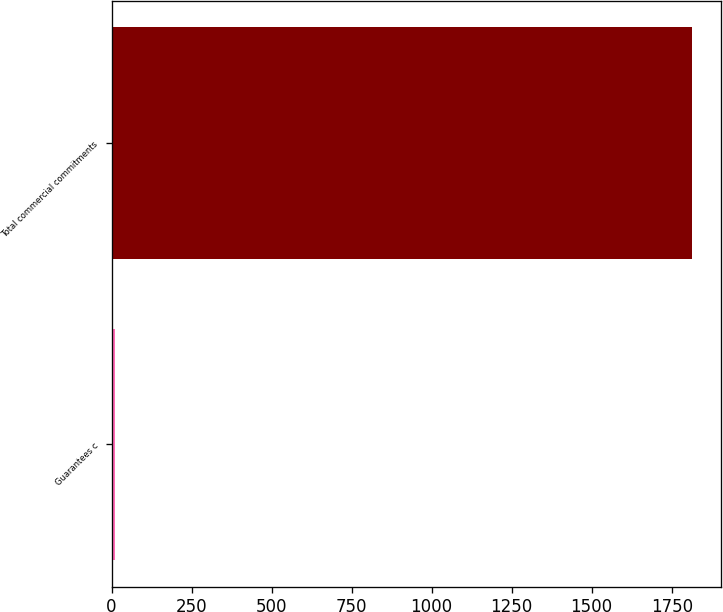Convert chart to OTSL. <chart><loc_0><loc_0><loc_500><loc_500><bar_chart><fcel>Guarantees c<fcel>Total commercial commitments<nl><fcel>12<fcel>1812<nl></chart> 